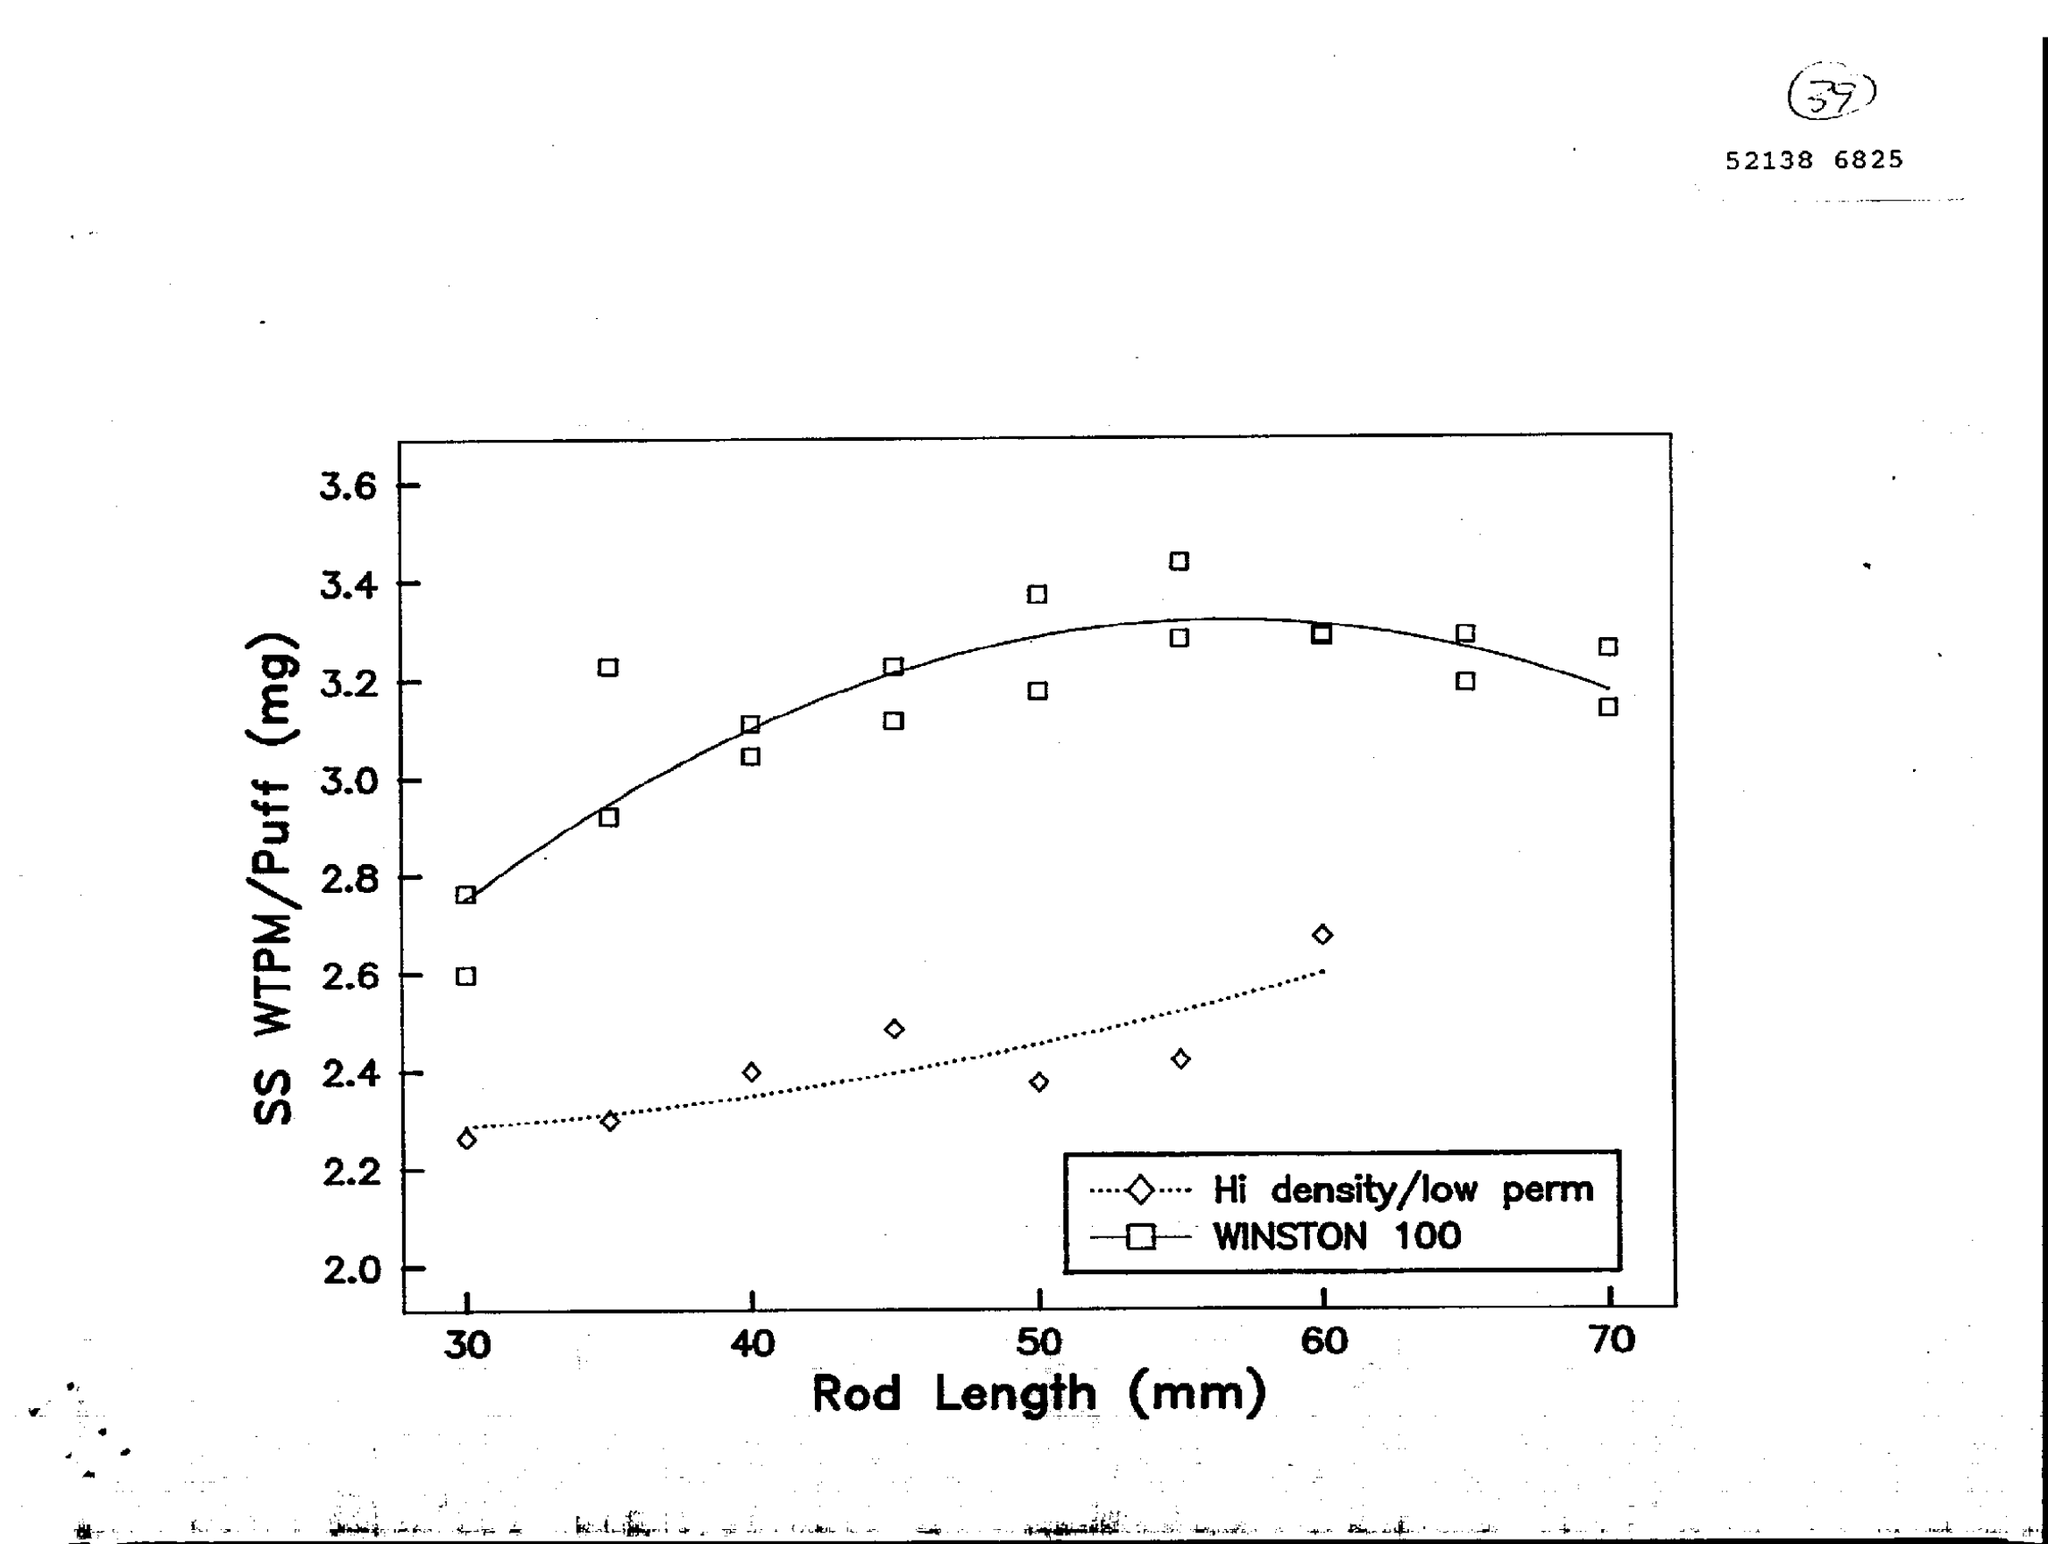What is the variable on X axis of the graph?
Give a very brief answer. Rod Length (mm). What is the variable on Y axis of the graph?
Provide a short and direct response. SS WTPM/Puff (mg). 